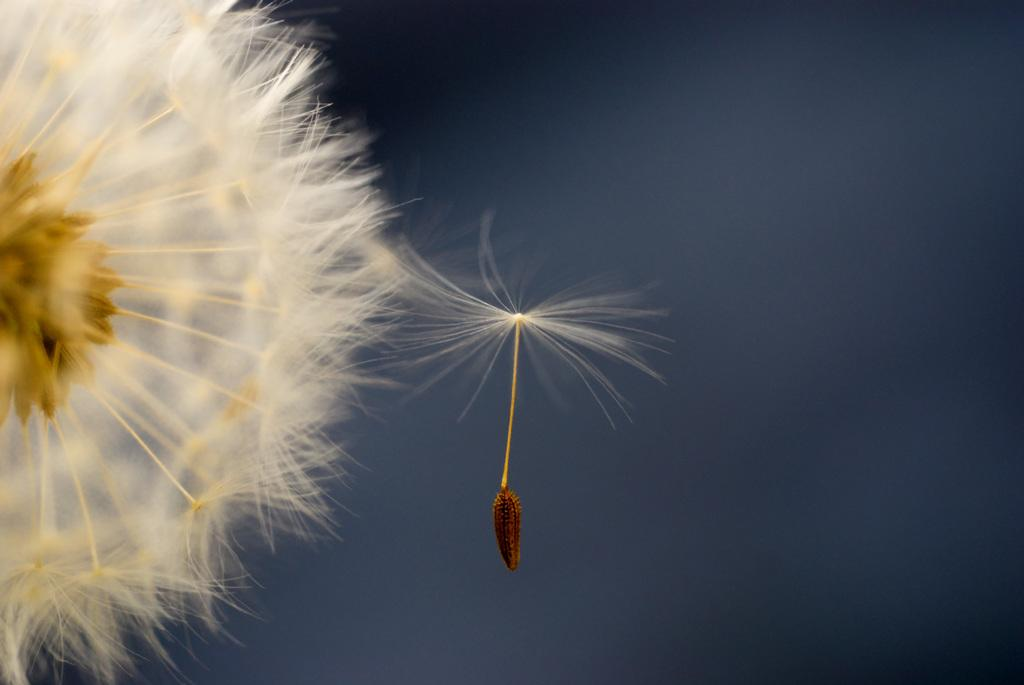What type of flower is in the image? There is a dandelion flower in the image. Can you describe the background of the image? The background of the image is blurry. What type of popcorn is being served in the image? There is no popcorn present in the image; it features a dandelion flower with a blurry background. 